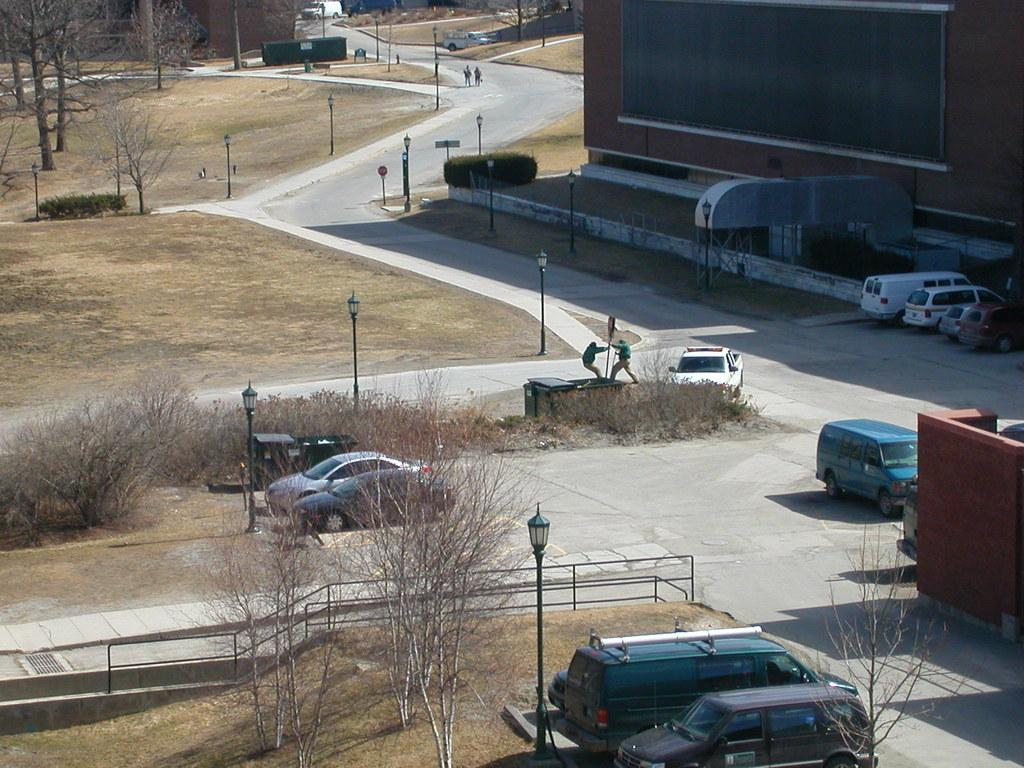What can be seen on the path in the image? There are vehicles on a path in the image. What is located on the left side of the vehicles? There are trees on the left side of the vehicles. What is situated on the right side of the vehicles? There are buildings on the right side of the vehicles. What type of spot is visible on the vehicles in the image? There is no mention of any spots on the vehicles in the image. 